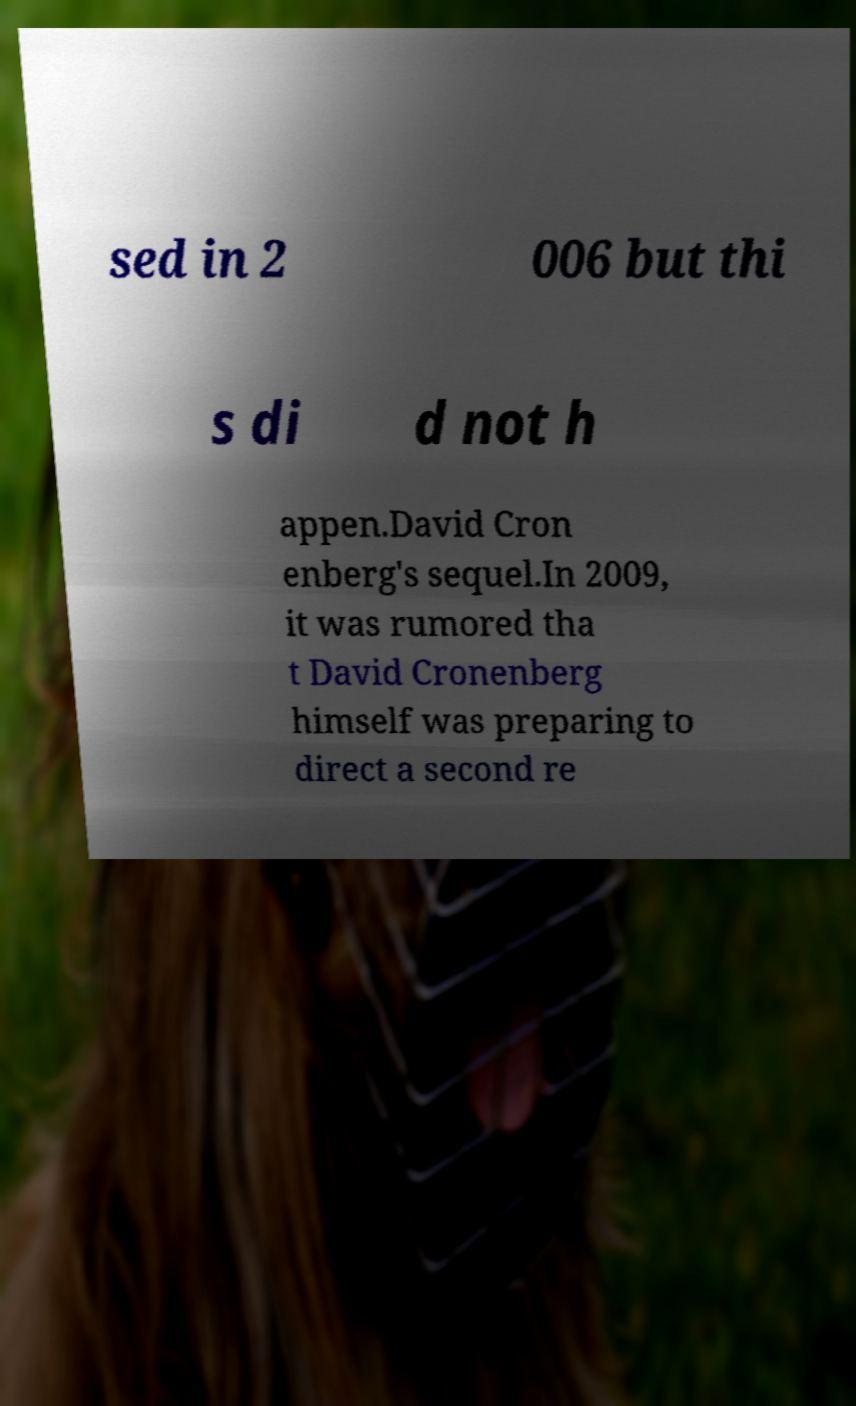Can you read and provide the text displayed in the image?This photo seems to have some interesting text. Can you extract and type it out for me? sed in 2 006 but thi s di d not h appen.David Cron enberg's sequel.In 2009, it was rumored tha t David Cronenberg himself was preparing to direct a second re 